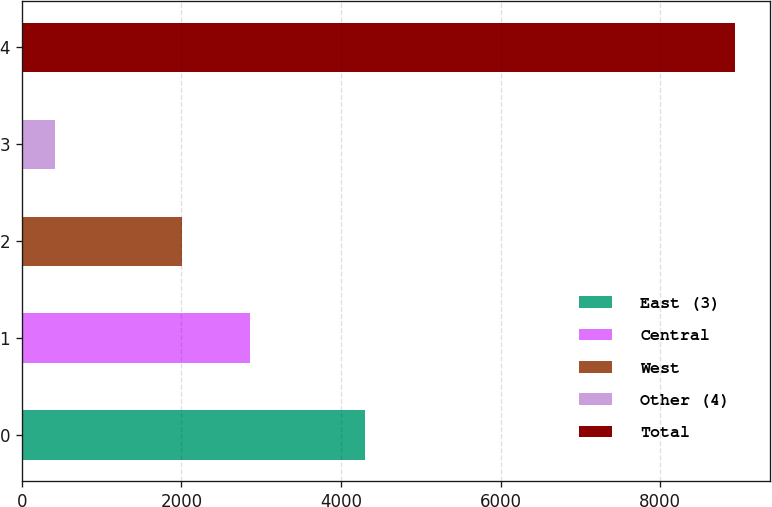Convert chart to OTSL. <chart><loc_0><loc_0><loc_500><loc_500><bar_chart><fcel>East (3)<fcel>Central<fcel>West<fcel>Other (4)<fcel>Total<nl><fcel>4300<fcel>2859<fcel>2007<fcel>415<fcel>8935<nl></chart> 